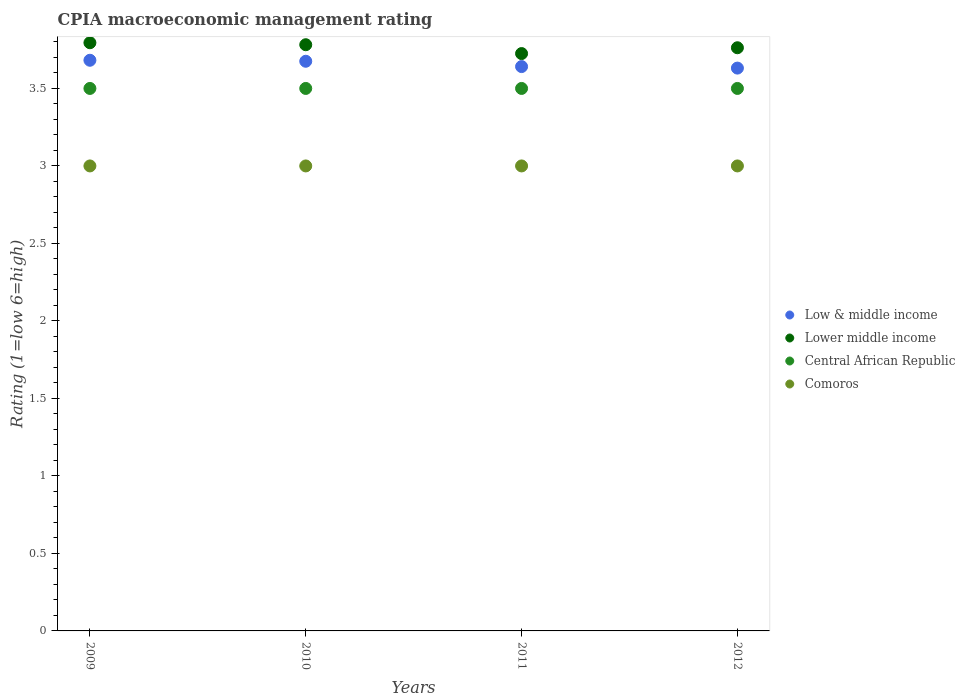Is the number of dotlines equal to the number of legend labels?
Offer a terse response. Yes. Across all years, what is the maximum CPIA rating in Lower middle income?
Offer a very short reply. 3.79. Across all years, what is the minimum CPIA rating in Low & middle income?
Keep it short and to the point. 3.63. In which year was the CPIA rating in Lower middle income maximum?
Ensure brevity in your answer.  2009. What is the difference between the CPIA rating in Central African Republic in 2009 and the CPIA rating in Comoros in 2012?
Ensure brevity in your answer.  0.5. What is the average CPIA rating in Low & middle income per year?
Ensure brevity in your answer.  3.66. In the year 2010, what is the difference between the CPIA rating in Comoros and CPIA rating in Central African Republic?
Offer a very short reply. -0.5. What is the ratio of the CPIA rating in Comoros in 2009 to that in 2010?
Your answer should be compact. 1. Is the difference between the CPIA rating in Comoros in 2009 and 2011 greater than the difference between the CPIA rating in Central African Republic in 2009 and 2011?
Keep it short and to the point. No. In how many years, is the CPIA rating in Lower middle income greater than the average CPIA rating in Lower middle income taken over all years?
Your answer should be compact. 2. Is it the case that in every year, the sum of the CPIA rating in Lower middle income and CPIA rating in Central African Republic  is greater than the sum of CPIA rating in Low & middle income and CPIA rating in Comoros?
Your answer should be compact. Yes. Does the CPIA rating in Comoros monotonically increase over the years?
Give a very brief answer. No. How many years are there in the graph?
Offer a terse response. 4. What is the difference between two consecutive major ticks on the Y-axis?
Your answer should be very brief. 0.5. Does the graph contain grids?
Offer a terse response. No. Where does the legend appear in the graph?
Ensure brevity in your answer.  Center right. How many legend labels are there?
Keep it short and to the point. 4. What is the title of the graph?
Keep it short and to the point. CPIA macroeconomic management rating. Does "Suriname" appear as one of the legend labels in the graph?
Offer a very short reply. No. What is the Rating (1=low 6=high) of Low & middle income in 2009?
Ensure brevity in your answer.  3.68. What is the Rating (1=low 6=high) in Lower middle income in 2009?
Your answer should be compact. 3.79. What is the Rating (1=low 6=high) in Comoros in 2009?
Ensure brevity in your answer.  3. What is the Rating (1=low 6=high) in Low & middle income in 2010?
Make the answer very short. 3.68. What is the Rating (1=low 6=high) of Lower middle income in 2010?
Offer a very short reply. 3.78. What is the Rating (1=low 6=high) in Central African Republic in 2010?
Your response must be concise. 3.5. What is the Rating (1=low 6=high) of Comoros in 2010?
Offer a very short reply. 3. What is the Rating (1=low 6=high) of Low & middle income in 2011?
Provide a succinct answer. 3.64. What is the Rating (1=low 6=high) of Lower middle income in 2011?
Give a very brief answer. 3.73. What is the Rating (1=low 6=high) of Comoros in 2011?
Offer a very short reply. 3. What is the Rating (1=low 6=high) in Low & middle income in 2012?
Provide a succinct answer. 3.63. What is the Rating (1=low 6=high) of Lower middle income in 2012?
Your answer should be very brief. 3.76. What is the Rating (1=low 6=high) in Central African Republic in 2012?
Offer a terse response. 3.5. Across all years, what is the maximum Rating (1=low 6=high) in Low & middle income?
Provide a succinct answer. 3.68. Across all years, what is the maximum Rating (1=low 6=high) in Lower middle income?
Provide a short and direct response. 3.79. Across all years, what is the minimum Rating (1=low 6=high) of Low & middle income?
Make the answer very short. 3.63. Across all years, what is the minimum Rating (1=low 6=high) in Lower middle income?
Your answer should be compact. 3.73. What is the total Rating (1=low 6=high) in Low & middle income in the graph?
Provide a short and direct response. 14.63. What is the total Rating (1=low 6=high) in Lower middle income in the graph?
Offer a very short reply. 15.06. What is the total Rating (1=low 6=high) of Central African Republic in the graph?
Your answer should be very brief. 14. What is the total Rating (1=low 6=high) of Comoros in the graph?
Your response must be concise. 12. What is the difference between the Rating (1=low 6=high) in Low & middle income in 2009 and that in 2010?
Offer a terse response. 0.01. What is the difference between the Rating (1=low 6=high) of Lower middle income in 2009 and that in 2010?
Your response must be concise. 0.01. What is the difference between the Rating (1=low 6=high) of Low & middle income in 2009 and that in 2011?
Give a very brief answer. 0.04. What is the difference between the Rating (1=low 6=high) in Lower middle income in 2009 and that in 2011?
Make the answer very short. 0.07. What is the difference between the Rating (1=low 6=high) of Central African Republic in 2009 and that in 2011?
Give a very brief answer. 0. What is the difference between the Rating (1=low 6=high) in Low & middle income in 2009 and that in 2012?
Provide a short and direct response. 0.05. What is the difference between the Rating (1=low 6=high) of Lower middle income in 2009 and that in 2012?
Keep it short and to the point. 0.03. What is the difference between the Rating (1=low 6=high) in Central African Republic in 2009 and that in 2012?
Ensure brevity in your answer.  0. What is the difference between the Rating (1=low 6=high) of Comoros in 2009 and that in 2012?
Offer a terse response. 0. What is the difference between the Rating (1=low 6=high) of Low & middle income in 2010 and that in 2011?
Provide a succinct answer. 0.03. What is the difference between the Rating (1=low 6=high) in Lower middle income in 2010 and that in 2011?
Provide a succinct answer. 0.06. What is the difference between the Rating (1=low 6=high) of Central African Republic in 2010 and that in 2011?
Ensure brevity in your answer.  0. What is the difference between the Rating (1=low 6=high) in Low & middle income in 2010 and that in 2012?
Keep it short and to the point. 0.04. What is the difference between the Rating (1=low 6=high) of Lower middle income in 2010 and that in 2012?
Your answer should be very brief. 0.02. What is the difference between the Rating (1=low 6=high) in Low & middle income in 2011 and that in 2012?
Provide a succinct answer. 0.01. What is the difference between the Rating (1=low 6=high) in Lower middle income in 2011 and that in 2012?
Give a very brief answer. -0.04. What is the difference between the Rating (1=low 6=high) in Comoros in 2011 and that in 2012?
Give a very brief answer. 0. What is the difference between the Rating (1=low 6=high) in Low & middle income in 2009 and the Rating (1=low 6=high) in Lower middle income in 2010?
Your answer should be compact. -0.1. What is the difference between the Rating (1=low 6=high) in Low & middle income in 2009 and the Rating (1=low 6=high) in Central African Republic in 2010?
Offer a very short reply. 0.18. What is the difference between the Rating (1=low 6=high) in Low & middle income in 2009 and the Rating (1=low 6=high) in Comoros in 2010?
Provide a short and direct response. 0.68. What is the difference between the Rating (1=low 6=high) of Lower middle income in 2009 and the Rating (1=low 6=high) of Central African Republic in 2010?
Your answer should be compact. 0.29. What is the difference between the Rating (1=low 6=high) of Lower middle income in 2009 and the Rating (1=low 6=high) of Comoros in 2010?
Offer a terse response. 0.79. What is the difference between the Rating (1=low 6=high) in Low & middle income in 2009 and the Rating (1=low 6=high) in Lower middle income in 2011?
Your response must be concise. -0.04. What is the difference between the Rating (1=low 6=high) in Low & middle income in 2009 and the Rating (1=low 6=high) in Central African Republic in 2011?
Offer a terse response. 0.18. What is the difference between the Rating (1=low 6=high) in Low & middle income in 2009 and the Rating (1=low 6=high) in Comoros in 2011?
Your answer should be compact. 0.68. What is the difference between the Rating (1=low 6=high) of Lower middle income in 2009 and the Rating (1=low 6=high) of Central African Republic in 2011?
Ensure brevity in your answer.  0.29. What is the difference between the Rating (1=low 6=high) in Lower middle income in 2009 and the Rating (1=low 6=high) in Comoros in 2011?
Your answer should be very brief. 0.79. What is the difference between the Rating (1=low 6=high) in Low & middle income in 2009 and the Rating (1=low 6=high) in Lower middle income in 2012?
Offer a terse response. -0.08. What is the difference between the Rating (1=low 6=high) in Low & middle income in 2009 and the Rating (1=low 6=high) in Central African Republic in 2012?
Provide a short and direct response. 0.18. What is the difference between the Rating (1=low 6=high) in Low & middle income in 2009 and the Rating (1=low 6=high) in Comoros in 2012?
Your answer should be compact. 0.68. What is the difference between the Rating (1=low 6=high) of Lower middle income in 2009 and the Rating (1=low 6=high) of Central African Republic in 2012?
Provide a succinct answer. 0.29. What is the difference between the Rating (1=low 6=high) of Lower middle income in 2009 and the Rating (1=low 6=high) of Comoros in 2012?
Offer a terse response. 0.79. What is the difference between the Rating (1=low 6=high) of Central African Republic in 2009 and the Rating (1=low 6=high) of Comoros in 2012?
Your answer should be compact. 0.5. What is the difference between the Rating (1=low 6=high) of Low & middle income in 2010 and the Rating (1=low 6=high) of Lower middle income in 2011?
Offer a terse response. -0.05. What is the difference between the Rating (1=low 6=high) of Low & middle income in 2010 and the Rating (1=low 6=high) of Central African Republic in 2011?
Ensure brevity in your answer.  0.18. What is the difference between the Rating (1=low 6=high) in Low & middle income in 2010 and the Rating (1=low 6=high) in Comoros in 2011?
Provide a succinct answer. 0.68. What is the difference between the Rating (1=low 6=high) of Lower middle income in 2010 and the Rating (1=low 6=high) of Central African Republic in 2011?
Give a very brief answer. 0.28. What is the difference between the Rating (1=low 6=high) in Lower middle income in 2010 and the Rating (1=low 6=high) in Comoros in 2011?
Ensure brevity in your answer.  0.78. What is the difference between the Rating (1=low 6=high) in Central African Republic in 2010 and the Rating (1=low 6=high) in Comoros in 2011?
Make the answer very short. 0.5. What is the difference between the Rating (1=low 6=high) of Low & middle income in 2010 and the Rating (1=low 6=high) of Lower middle income in 2012?
Provide a short and direct response. -0.09. What is the difference between the Rating (1=low 6=high) of Low & middle income in 2010 and the Rating (1=low 6=high) of Central African Republic in 2012?
Offer a very short reply. 0.18. What is the difference between the Rating (1=low 6=high) of Low & middle income in 2010 and the Rating (1=low 6=high) of Comoros in 2012?
Keep it short and to the point. 0.68. What is the difference between the Rating (1=low 6=high) of Lower middle income in 2010 and the Rating (1=low 6=high) of Central African Republic in 2012?
Ensure brevity in your answer.  0.28. What is the difference between the Rating (1=low 6=high) in Lower middle income in 2010 and the Rating (1=low 6=high) in Comoros in 2012?
Offer a very short reply. 0.78. What is the difference between the Rating (1=low 6=high) of Low & middle income in 2011 and the Rating (1=low 6=high) of Lower middle income in 2012?
Your answer should be very brief. -0.12. What is the difference between the Rating (1=low 6=high) of Low & middle income in 2011 and the Rating (1=low 6=high) of Central African Republic in 2012?
Keep it short and to the point. 0.14. What is the difference between the Rating (1=low 6=high) in Low & middle income in 2011 and the Rating (1=low 6=high) in Comoros in 2012?
Offer a terse response. 0.64. What is the difference between the Rating (1=low 6=high) of Lower middle income in 2011 and the Rating (1=low 6=high) of Central African Republic in 2012?
Your answer should be compact. 0.23. What is the difference between the Rating (1=low 6=high) of Lower middle income in 2011 and the Rating (1=low 6=high) of Comoros in 2012?
Ensure brevity in your answer.  0.72. What is the average Rating (1=low 6=high) of Low & middle income per year?
Provide a short and direct response. 3.66. What is the average Rating (1=low 6=high) in Lower middle income per year?
Your response must be concise. 3.77. In the year 2009, what is the difference between the Rating (1=low 6=high) of Low & middle income and Rating (1=low 6=high) of Lower middle income?
Give a very brief answer. -0.11. In the year 2009, what is the difference between the Rating (1=low 6=high) of Low & middle income and Rating (1=low 6=high) of Central African Republic?
Give a very brief answer. 0.18. In the year 2009, what is the difference between the Rating (1=low 6=high) of Low & middle income and Rating (1=low 6=high) of Comoros?
Give a very brief answer. 0.68. In the year 2009, what is the difference between the Rating (1=low 6=high) in Lower middle income and Rating (1=low 6=high) in Central African Republic?
Give a very brief answer. 0.29. In the year 2009, what is the difference between the Rating (1=low 6=high) in Lower middle income and Rating (1=low 6=high) in Comoros?
Offer a very short reply. 0.79. In the year 2009, what is the difference between the Rating (1=low 6=high) in Central African Republic and Rating (1=low 6=high) in Comoros?
Provide a short and direct response. 0.5. In the year 2010, what is the difference between the Rating (1=low 6=high) in Low & middle income and Rating (1=low 6=high) in Lower middle income?
Offer a very short reply. -0.11. In the year 2010, what is the difference between the Rating (1=low 6=high) in Low & middle income and Rating (1=low 6=high) in Central African Republic?
Ensure brevity in your answer.  0.18. In the year 2010, what is the difference between the Rating (1=low 6=high) of Low & middle income and Rating (1=low 6=high) of Comoros?
Offer a terse response. 0.68. In the year 2010, what is the difference between the Rating (1=low 6=high) in Lower middle income and Rating (1=low 6=high) in Central African Republic?
Ensure brevity in your answer.  0.28. In the year 2010, what is the difference between the Rating (1=low 6=high) in Lower middle income and Rating (1=low 6=high) in Comoros?
Ensure brevity in your answer.  0.78. In the year 2010, what is the difference between the Rating (1=low 6=high) in Central African Republic and Rating (1=low 6=high) in Comoros?
Keep it short and to the point. 0.5. In the year 2011, what is the difference between the Rating (1=low 6=high) of Low & middle income and Rating (1=low 6=high) of Lower middle income?
Keep it short and to the point. -0.08. In the year 2011, what is the difference between the Rating (1=low 6=high) of Low & middle income and Rating (1=low 6=high) of Central African Republic?
Your answer should be compact. 0.14. In the year 2011, what is the difference between the Rating (1=low 6=high) in Low & middle income and Rating (1=low 6=high) in Comoros?
Ensure brevity in your answer.  0.64. In the year 2011, what is the difference between the Rating (1=low 6=high) in Lower middle income and Rating (1=low 6=high) in Central African Republic?
Your response must be concise. 0.23. In the year 2011, what is the difference between the Rating (1=low 6=high) in Lower middle income and Rating (1=low 6=high) in Comoros?
Make the answer very short. 0.72. In the year 2012, what is the difference between the Rating (1=low 6=high) of Low & middle income and Rating (1=low 6=high) of Lower middle income?
Offer a very short reply. -0.13. In the year 2012, what is the difference between the Rating (1=low 6=high) in Low & middle income and Rating (1=low 6=high) in Central African Republic?
Your response must be concise. 0.13. In the year 2012, what is the difference between the Rating (1=low 6=high) in Low & middle income and Rating (1=low 6=high) in Comoros?
Ensure brevity in your answer.  0.63. In the year 2012, what is the difference between the Rating (1=low 6=high) in Lower middle income and Rating (1=low 6=high) in Central African Republic?
Ensure brevity in your answer.  0.26. In the year 2012, what is the difference between the Rating (1=low 6=high) in Lower middle income and Rating (1=low 6=high) in Comoros?
Make the answer very short. 0.76. What is the ratio of the Rating (1=low 6=high) of Central African Republic in 2009 to that in 2010?
Offer a very short reply. 1. What is the ratio of the Rating (1=low 6=high) of Comoros in 2009 to that in 2010?
Offer a very short reply. 1. What is the ratio of the Rating (1=low 6=high) of Low & middle income in 2009 to that in 2011?
Ensure brevity in your answer.  1.01. What is the ratio of the Rating (1=low 6=high) in Lower middle income in 2009 to that in 2011?
Offer a very short reply. 1.02. What is the ratio of the Rating (1=low 6=high) of Low & middle income in 2009 to that in 2012?
Keep it short and to the point. 1.01. What is the ratio of the Rating (1=low 6=high) of Lower middle income in 2009 to that in 2012?
Give a very brief answer. 1.01. What is the ratio of the Rating (1=low 6=high) in Low & middle income in 2010 to that in 2011?
Your answer should be compact. 1.01. What is the ratio of the Rating (1=low 6=high) of Lower middle income in 2010 to that in 2011?
Your answer should be compact. 1.02. What is the ratio of the Rating (1=low 6=high) in Central African Republic in 2010 to that in 2011?
Make the answer very short. 1. What is the ratio of the Rating (1=low 6=high) of Low & middle income in 2010 to that in 2012?
Give a very brief answer. 1.01. What is the ratio of the Rating (1=low 6=high) of Central African Republic in 2010 to that in 2012?
Your response must be concise. 1. What is the ratio of the Rating (1=low 6=high) in Low & middle income in 2011 to that in 2012?
Ensure brevity in your answer.  1. What is the ratio of the Rating (1=low 6=high) in Lower middle income in 2011 to that in 2012?
Your answer should be compact. 0.99. What is the ratio of the Rating (1=low 6=high) in Central African Republic in 2011 to that in 2012?
Give a very brief answer. 1. What is the difference between the highest and the second highest Rating (1=low 6=high) of Low & middle income?
Your response must be concise. 0.01. What is the difference between the highest and the second highest Rating (1=low 6=high) in Lower middle income?
Make the answer very short. 0.01. What is the difference between the highest and the lowest Rating (1=low 6=high) in Low & middle income?
Your answer should be very brief. 0.05. What is the difference between the highest and the lowest Rating (1=low 6=high) in Lower middle income?
Offer a terse response. 0.07. 